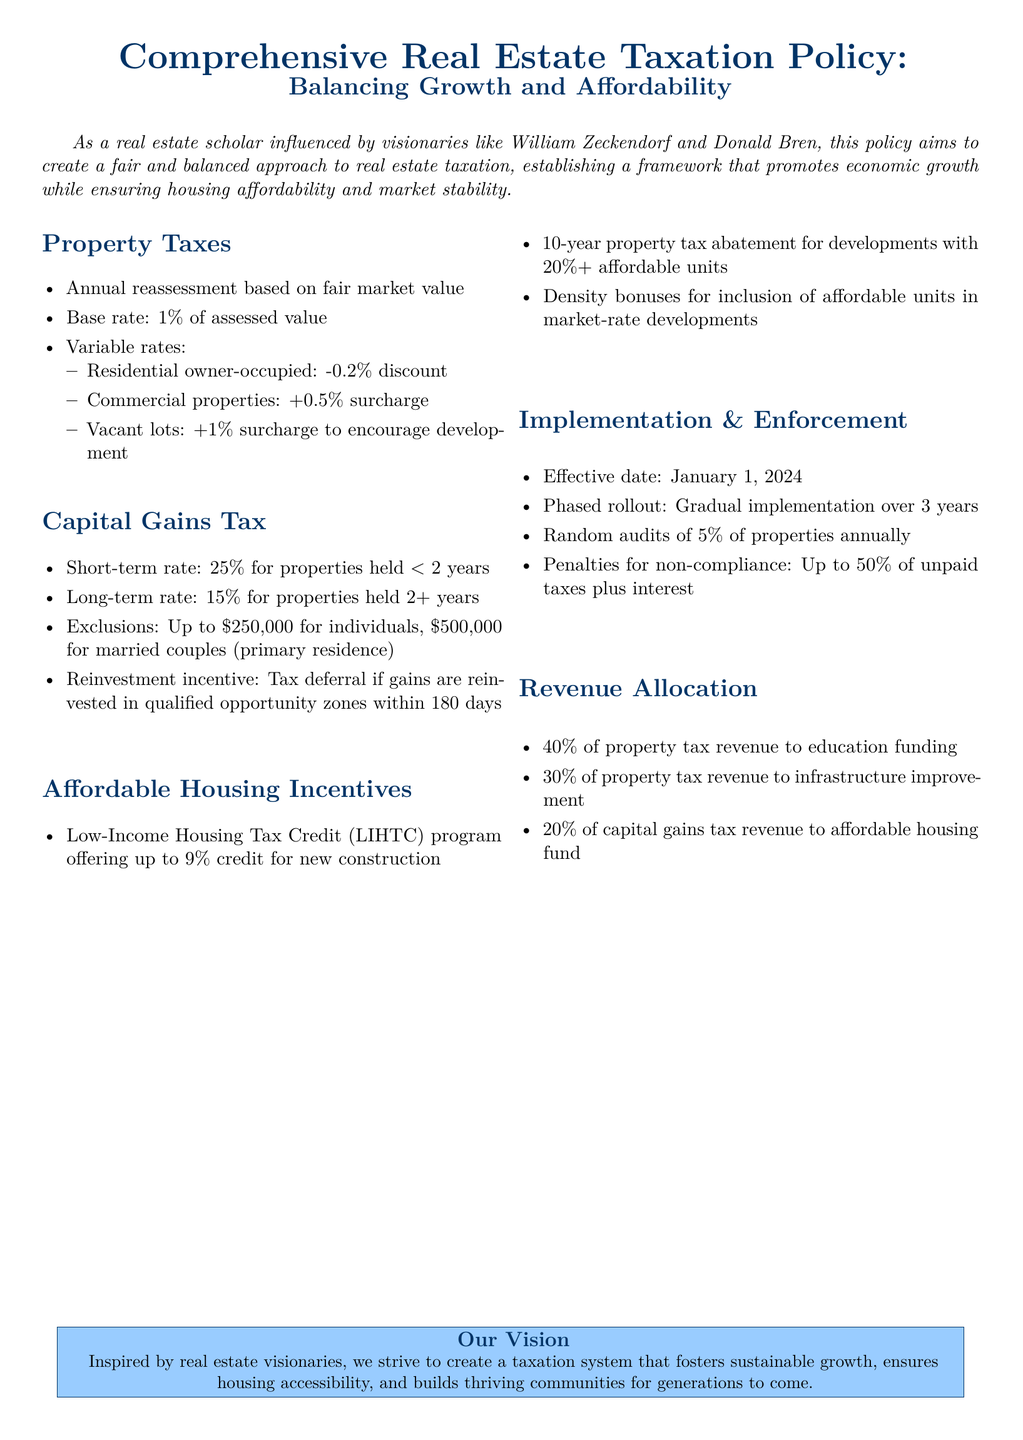what is the base property tax rate? The document states the base rate for property taxes is 1% of assessed value.
Answer: 1% what is the short-term capital gains tax rate? The short-term capital gains tax for properties held for less than 2 years is 25%.
Answer: 25% what percentage of property tax revenue is allocated to education funding? The document specifies that 40% of property tax revenue is allocated to education funding.
Answer: 40% what is the penalty for non-compliance? The document outlines a penalty for non-compliance of up to 50% of unpaid taxes plus interest.
Answer: Up to 50% what is the property tax abatement duration for developments with 20% or more affordable units? The document mentions a 10-year property tax abatement for such developments.
Answer: 10 years how much is the Low-Income Housing Tax Credit for new construction? According to the document, the LIHTC program offers up to 9% credit for new construction.
Answer: 9% what is the effective date of the policy? The policy is set to take effect on January 1, 2024.
Answer: January 1, 2024 how much capital gains tax revenue is allocated to the affordable housing fund? The document specifies that 20% of capital gains tax revenue is allocated to the affordable housing fund.
Answer: 20% what is the proposed duration for the phased rollout of the policy? The document states that the phased rollout will be gradual over 3 years.
Answer: 3 years 